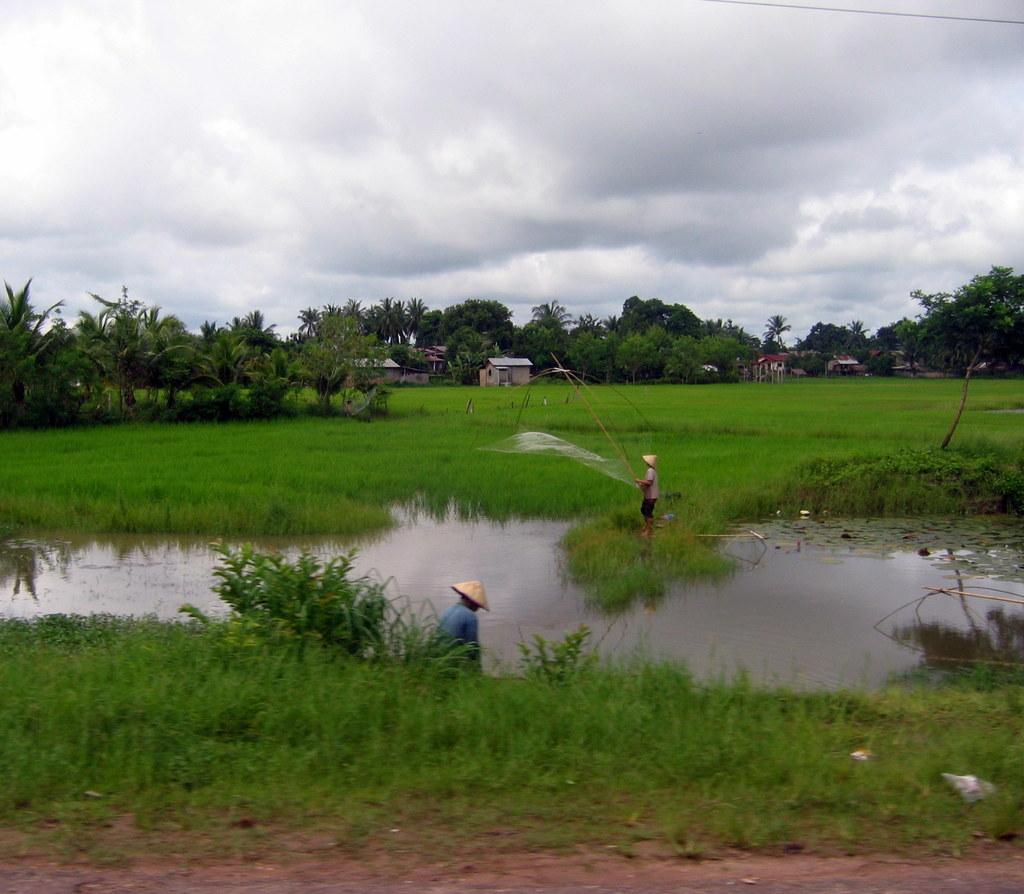What type of water feature is present in the image? There is a canal in the image. How many people are in the image? There are two persons in the image. What are the people wearing? The persons are wearing clothes. What can be seen in the background of the image? There are trees and the sky visible in the background of the image. What is the price of the creator's latest artwork in the image? There is no artwork or creator mentioned in the image; it features a canal and two people. 